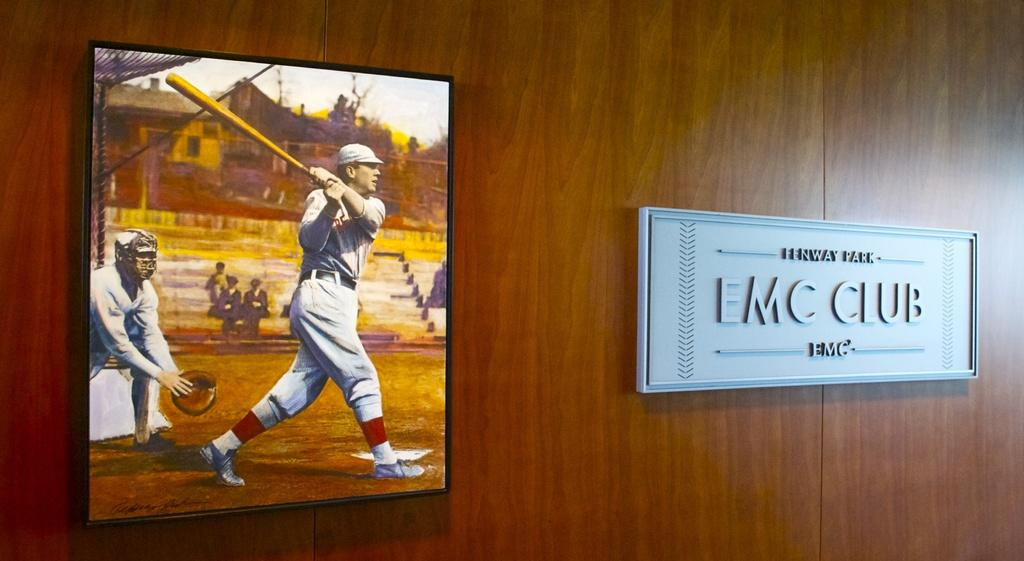<image>
Create a compact narrative representing the image presented. A picture hangs on a wall of a baseball player with a sign next to it that says Fenway Park EMC Club. 